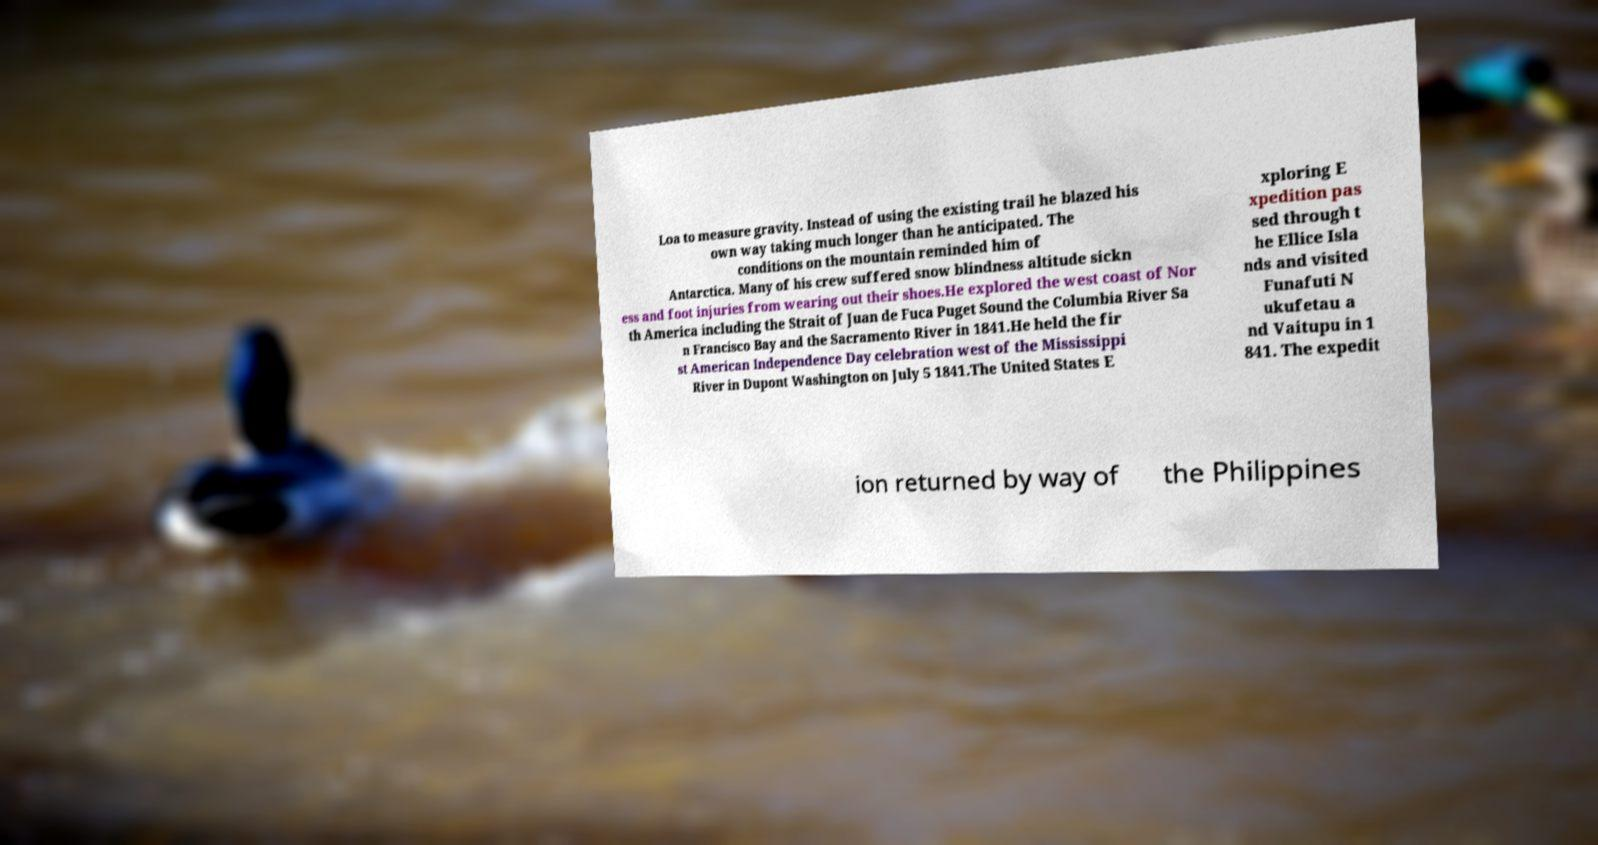For documentation purposes, I need the text within this image transcribed. Could you provide that? Loa to measure gravity. Instead of using the existing trail he blazed his own way taking much longer than he anticipated. The conditions on the mountain reminded him of Antarctica. Many of his crew suffered snow blindness altitude sickn ess and foot injuries from wearing out their shoes.He explored the west coast of Nor th America including the Strait of Juan de Fuca Puget Sound the Columbia River Sa n Francisco Bay and the Sacramento River in 1841.He held the fir st American Independence Day celebration west of the Mississippi River in Dupont Washington on July 5 1841.The United States E xploring E xpedition pas sed through t he Ellice Isla nds and visited Funafuti N ukufetau a nd Vaitupu in 1 841. The expedit ion returned by way of the Philippines 